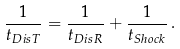Convert formula to latex. <formula><loc_0><loc_0><loc_500><loc_500>\frac { 1 } { t _ { D i s T } } = \frac { 1 } { t _ { D i s R } } + \frac { 1 } { t _ { S h o c k } } \, .</formula> 